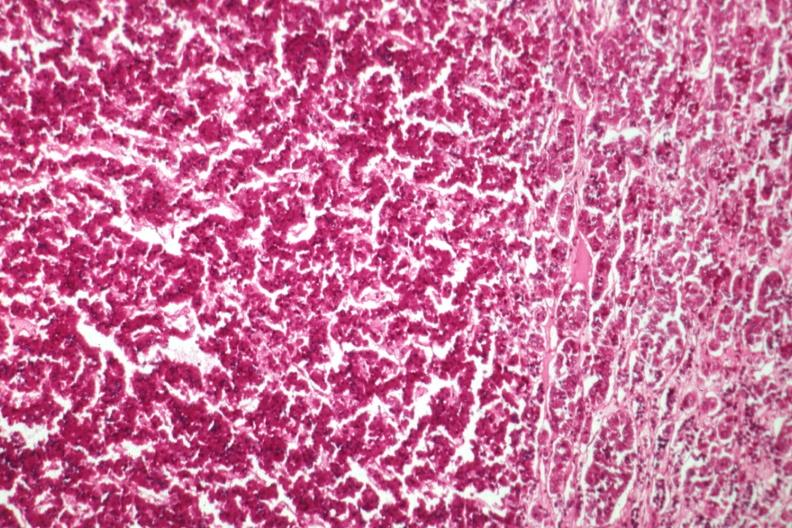what is present?
Answer the question using a single word or phrase. Pituitary 